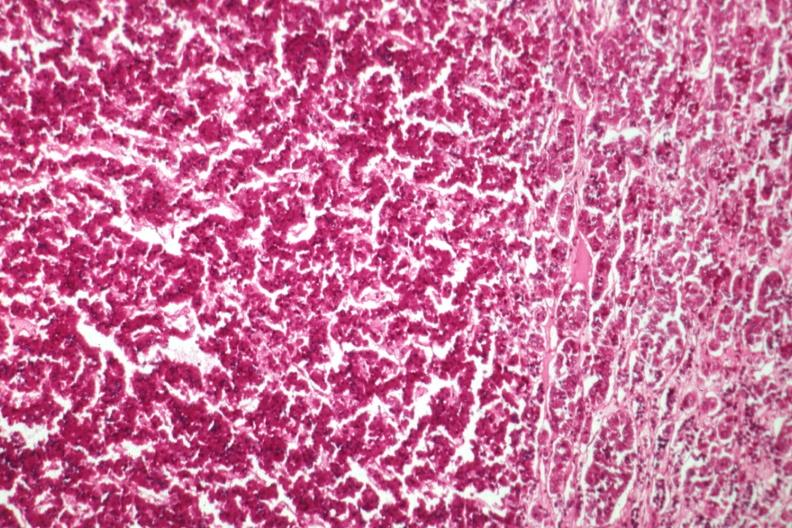what is present?
Answer the question using a single word or phrase. Pituitary 